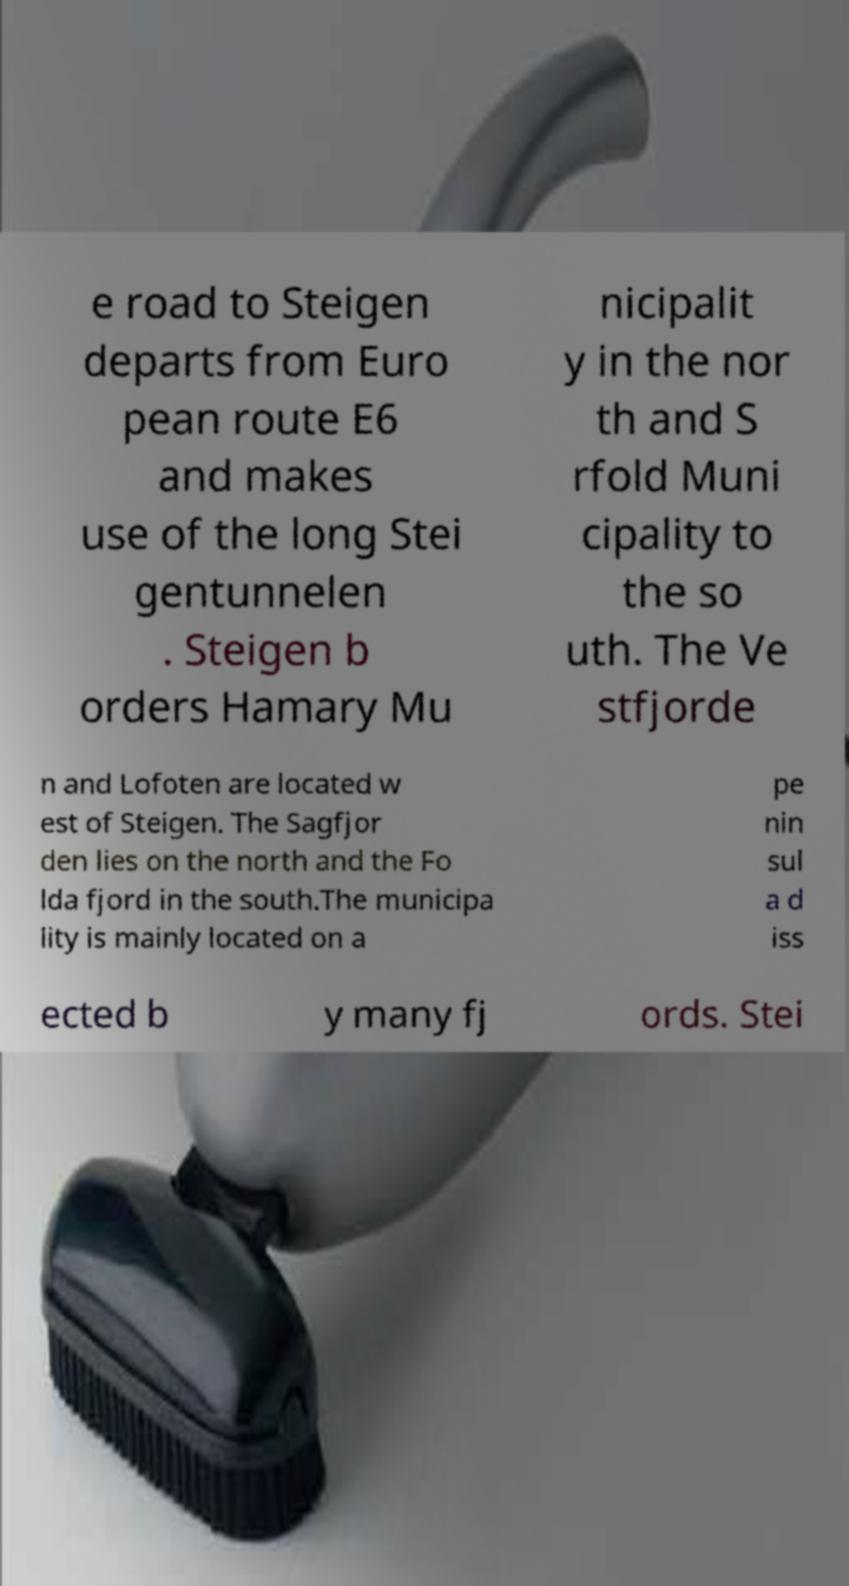Please read and relay the text visible in this image. What does it say? e road to Steigen departs from Euro pean route E6 and makes use of the long Stei gentunnelen . Steigen b orders Hamary Mu nicipalit y in the nor th and S rfold Muni cipality to the so uth. The Ve stfjorde n and Lofoten are located w est of Steigen. The Sagfjor den lies on the north and the Fo lda fjord in the south.The municipa lity is mainly located on a pe nin sul a d iss ected b y many fj ords. Stei 